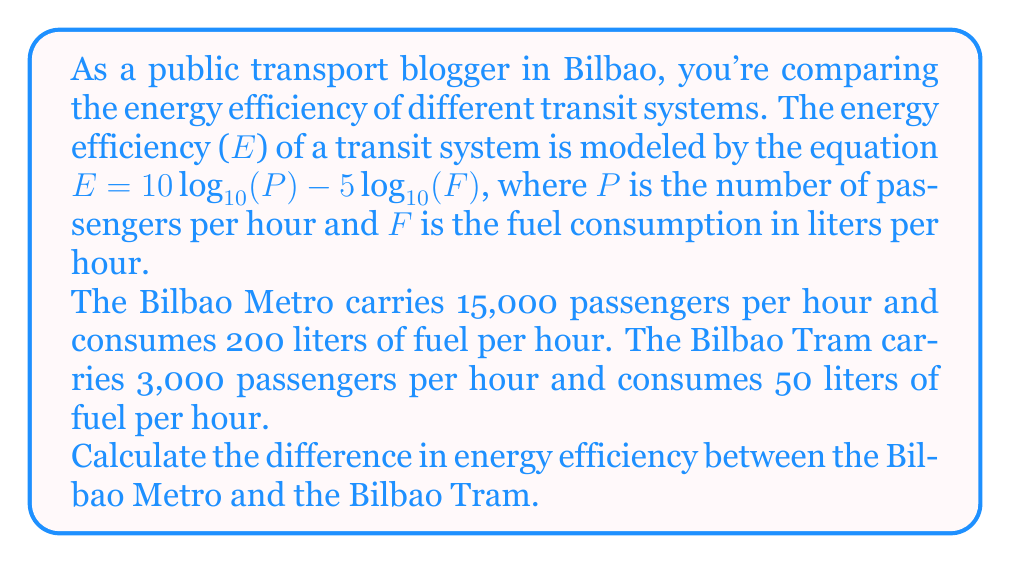Show me your answer to this math problem. Let's approach this step-by-step:

1) First, we'll calculate the energy efficiency for the Bilbao Metro:

   $E_{metro} = 10 \log_{10}(15000) - 5 \log_{10}(200)$

2) Then, we'll calculate the energy efficiency for the Bilbao Tram:

   $E_{tram} = 10 \log_{10}(3000) - 5 \log_{10}(50)$

3) For the Metro:
   $E_{metro} = 10 \cdot 4.1761 - 5 \cdot 2.3010$
              $= 41.761 - 11.505$
              $= 30.256$

4) For the Tram:
   $E_{tram} = 10 \cdot 3.4771 - 5 \cdot 1.6990$
             $= 34.771 - 8.495$
             $= 26.276$

5) The difference in energy efficiency is:
   $\Delta E = E_{metro} - E_{tram}$
             $= 30.256 - 26.276$
             $= 3.980$

Therefore, the Bilbao Metro is approximately 3.980 units more energy-efficient than the Bilbao Tram according to this model.
Answer: The difference in energy efficiency between the Bilbao Metro and the Bilbao Tram is approximately 3.980 units. 